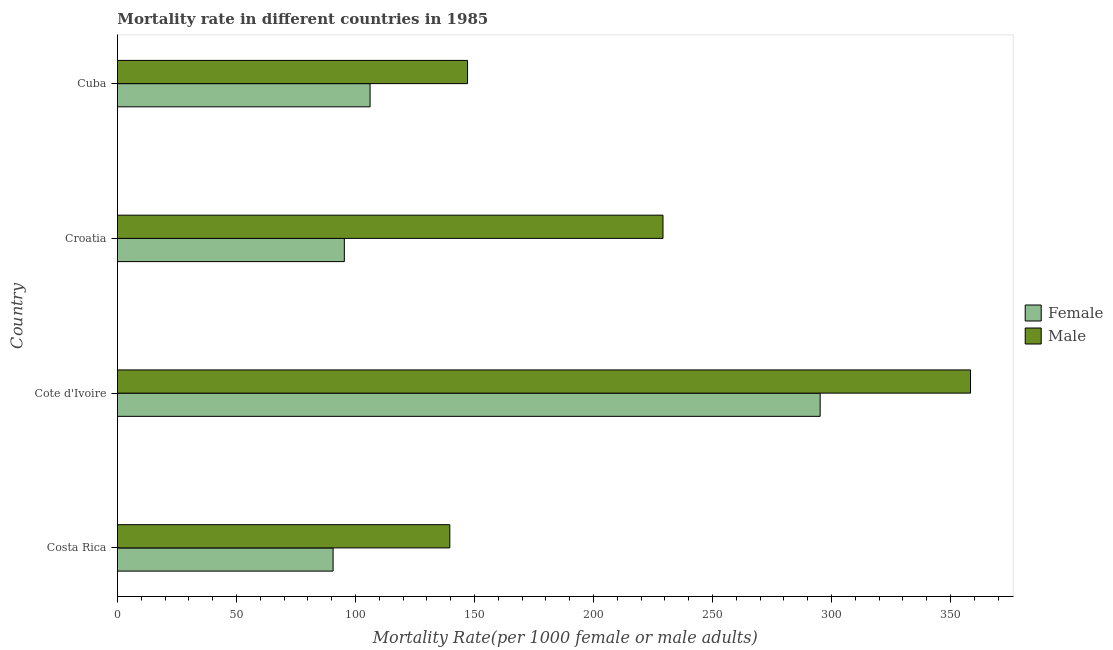How many groups of bars are there?
Ensure brevity in your answer.  4. Are the number of bars per tick equal to the number of legend labels?
Provide a short and direct response. Yes. Are the number of bars on each tick of the Y-axis equal?
Give a very brief answer. Yes. How many bars are there on the 4th tick from the bottom?
Offer a terse response. 2. What is the label of the 2nd group of bars from the top?
Your response must be concise. Croatia. What is the female mortality rate in Cote d'Ivoire?
Give a very brief answer. 295.27. Across all countries, what is the maximum female mortality rate?
Provide a succinct answer. 295.27. Across all countries, what is the minimum male mortality rate?
Keep it short and to the point. 139.66. In which country was the female mortality rate maximum?
Provide a short and direct response. Cote d'Ivoire. What is the total female mortality rate in the graph?
Keep it short and to the point. 587.4. What is the difference between the female mortality rate in Cote d'Ivoire and that in Croatia?
Offer a very short reply. 199.92. What is the difference between the male mortality rate in Cote d'Ivoire and the female mortality rate in Cuba?
Ensure brevity in your answer.  252.29. What is the average female mortality rate per country?
Give a very brief answer. 146.85. What is the difference between the female mortality rate and male mortality rate in Costa Rica?
Make the answer very short. -49.04. What is the ratio of the male mortality rate in Cote d'Ivoire to that in Croatia?
Make the answer very short. 1.56. What is the difference between the highest and the second highest female mortality rate?
Your response must be concise. 189.11. What is the difference between the highest and the lowest female mortality rate?
Provide a short and direct response. 204.64. In how many countries, is the female mortality rate greater than the average female mortality rate taken over all countries?
Offer a very short reply. 1. What does the 2nd bar from the top in Croatia represents?
Offer a terse response. Female. Are all the bars in the graph horizontal?
Your response must be concise. Yes. What is the difference between two consecutive major ticks on the X-axis?
Offer a terse response. 50. Does the graph contain grids?
Offer a terse response. No. Where does the legend appear in the graph?
Ensure brevity in your answer.  Center right. How many legend labels are there?
Offer a terse response. 2. How are the legend labels stacked?
Provide a short and direct response. Vertical. What is the title of the graph?
Your answer should be compact. Mortality rate in different countries in 1985. What is the label or title of the X-axis?
Offer a terse response. Mortality Rate(per 1000 female or male adults). What is the label or title of the Y-axis?
Offer a terse response. Country. What is the Mortality Rate(per 1000 female or male adults) of Female in Costa Rica?
Your answer should be compact. 90.63. What is the Mortality Rate(per 1000 female or male adults) of Male in Costa Rica?
Make the answer very short. 139.66. What is the Mortality Rate(per 1000 female or male adults) in Female in Cote d'Ivoire?
Your answer should be very brief. 295.27. What is the Mortality Rate(per 1000 female or male adults) in Male in Cote d'Ivoire?
Ensure brevity in your answer.  358.45. What is the Mortality Rate(per 1000 female or male adults) in Female in Croatia?
Make the answer very short. 95.34. What is the Mortality Rate(per 1000 female or male adults) of Male in Croatia?
Ensure brevity in your answer.  229.24. What is the Mortality Rate(per 1000 female or male adults) of Female in Cuba?
Provide a short and direct response. 106.16. What is the Mortality Rate(per 1000 female or male adults) of Male in Cuba?
Make the answer very short. 147.11. Across all countries, what is the maximum Mortality Rate(per 1000 female or male adults) of Female?
Keep it short and to the point. 295.27. Across all countries, what is the maximum Mortality Rate(per 1000 female or male adults) in Male?
Provide a short and direct response. 358.45. Across all countries, what is the minimum Mortality Rate(per 1000 female or male adults) in Female?
Offer a very short reply. 90.63. Across all countries, what is the minimum Mortality Rate(per 1000 female or male adults) in Male?
Your answer should be very brief. 139.66. What is the total Mortality Rate(per 1000 female or male adults) in Female in the graph?
Offer a very short reply. 587.4. What is the total Mortality Rate(per 1000 female or male adults) in Male in the graph?
Offer a terse response. 874.46. What is the difference between the Mortality Rate(per 1000 female or male adults) in Female in Costa Rica and that in Cote d'Ivoire?
Make the answer very short. -204.64. What is the difference between the Mortality Rate(per 1000 female or male adults) of Male in Costa Rica and that in Cote d'Ivoire?
Make the answer very short. -218.79. What is the difference between the Mortality Rate(per 1000 female or male adults) in Female in Costa Rica and that in Croatia?
Provide a short and direct response. -4.72. What is the difference between the Mortality Rate(per 1000 female or male adults) of Male in Costa Rica and that in Croatia?
Your answer should be compact. -89.57. What is the difference between the Mortality Rate(per 1000 female or male adults) in Female in Costa Rica and that in Cuba?
Give a very brief answer. -15.54. What is the difference between the Mortality Rate(per 1000 female or male adults) in Male in Costa Rica and that in Cuba?
Keep it short and to the point. -7.45. What is the difference between the Mortality Rate(per 1000 female or male adults) in Female in Cote d'Ivoire and that in Croatia?
Provide a succinct answer. 199.92. What is the difference between the Mortality Rate(per 1000 female or male adults) of Male in Cote d'Ivoire and that in Croatia?
Your answer should be very brief. 129.21. What is the difference between the Mortality Rate(per 1000 female or male adults) in Female in Cote d'Ivoire and that in Cuba?
Ensure brevity in your answer.  189.11. What is the difference between the Mortality Rate(per 1000 female or male adults) of Male in Cote d'Ivoire and that in Cuba?
Give a very brief answer. 211.34. What is the difference between the Mortality Rate(per 1000 female or male adults) of Female in Croatia and that in Cuba?
Offer a terse response. -10.82. What is the difference between the Mortality Rate(per 1000 female or male adults) in Male in Croatia and that in Cuba?
Offer a very short reply. 82.12. What is the difference between the Mortality Rate(per 1000 female or male adults) of Female in Costa Rica and the Mortality Rate(per 1000 female or male adults) of Male in Cote d'Ivoire?
Your answer should be very brief. -267.82. What is the difference between the Mortality Rate(per 1000 female or male adults) in Female in Costa Rica and the Mortality Rate(per 1000 female or male adults) in Male in Croatia?
Offer a terse response. -138.61. What is the difference between the Mortality Rate(per 1000 female or male adults) in Female in Costa Rica and the Mortality Rate(per 1000 female or male adults) in Male in Cuba?
Provide a short and direct response. -56.49. What is the difference between the Mortality Rate(per 1000 female or male adults) of Female in Cote d'Ivoire and the Mortality Rate(per 1000 female or male adults) of Male in Croatia?
Ensure brevity in your answer.  66.03. What is the difference between the Mortality Rate(per 1000 female or male adults) of Female in Cote d'Ivoire and the Mortality Rate(per 1000 female or male adults) of Male in Cuba?
Your response must be concise. 148.15. What is the difference between the Mortality Rate(per 1000 female or male adults) of Female in Croatia and the Mortality Rate(per 1000 female or male adults) of Male in Cuba?
Make the answer very short. -51.77. What is the average Mortality Rate(per 1000 female or male adults) of Female per country?
Give a very brief answer. 146.85. What is the average Mortality Rate(per 1000 female or male adults) of Male per country?
Provide a succinct answer. 218.61. What is the difference between the Mortality Rate(per 1000 female or male adults) in Female and Mortality Rate(per 1000 female or male adults) in Male in Costa Rica?
Your response must be concise. -49.04. What is the difference between the Mortality Rate(per 1000 female or male adults) of Female and Mortality Rate(per 1000 female or male adults) of Male in Cote d'Ivoire?
Make the answer very short. -63.18. What is the difference between the Mortality Rate(per 1000 female or male adults) of Female and Mortality Rate(per 1000 female or male adults) of Male in Croatia?
Make the answer very short. -133.89. What is the difference between the Mortality Rate(per 1000 female or male adults) of Female and Mortality Rate(per 1000 female or male adults) of Male in Cuba?
Make the answer very short. -40.95. What is the ratio of the Mortality Rate(per 1000 female or male adults) of Female in Costa Rica to that in Cote d'Ivoire?
Provide a short and direct response. 0.31. What is the ratio of the Mortality Rate(per 1000 female or male adults) of Male in Costa Rica to that in Cote d'Ivoire?
Make the answer very short. 0.39. What is the ratio of the Mortality Rate(per 1000 female or male adults) of Female in Costa Rica to that in Croatia?
Offer a terse response. 0.95. What is the ratio of the Mortality Rate(per 1000 female or male adults) of Male in Costa Rica to that in Croatia?
Offer a terse response. 0.61. What is the ratio of the Mortality Rate(per 1000 female or male adults) of Female in Costa Rica to that in Cuba?
Your response must be concise. 0.85. What is the ratio of the Mortality Rate(per 1000 female or male adults) of Male in Costa Rica to that in Cuba?
Offer a very short reply. 0.95. What is the ratio of the Mortality Rate(per 1000 female or male adults) in Female in Cote d'Ivoire to that in Croatia?
Give a very brief answer. 3.1. What is the ratio of the Mortality Rate(per 1000 female or male adults) of Male in Cote d'Ivoire to that in Croatia?
Make the answer very short. 1.56. What is the ratio of the Mortality Rate(per 1000 female or male adults) in Female in Cote d'Ivoire to that in Cuba?
Provide a succinct answer. 2.78. What is the ratio of the Mortality Rate(per 1000 female or male adults) of Male in Cote d'Ivoire to that in Cuba?
Make the answer very short. 2.44. What is the ratio of the Mortality Rate(per 1000 female or male adults) in Female in Croatia to that in Cuba?
Offer a terse response. 0.9. What is the ratio of the Mortality Rate(per 1000 female or male adults) of Male in Croatia to that in Cuba?
Your response must be concise. 1.56. What is the difference between the highest and the second highest Mortality Rate(per 1000 female or male adults) in Female?
Give a very brief answer. 189.11. What is the difference between the highest and the second highest Mortality Rate(per 1000 female or male adults) of Male?
Give a very brief answer. 129.21. What is the difference between the highest and the lowest Mortality Rate(per 1000 female or male adults) of Female?
Offer a very short reply. 204.64. What is the difference between the highest and the lowest Mortality Rate(per 1000 female or male adults) in Male?
Make the answer very short. 218.79. 